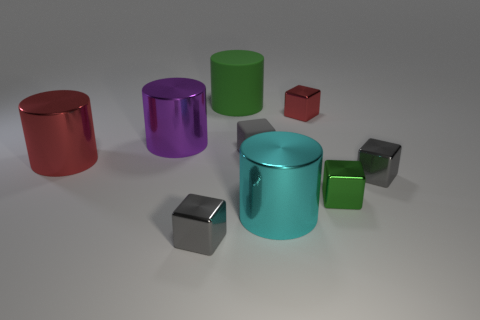Subtract all big metallic cylinders. How many cylinders are left? 1 Subtract all gray cylinders. How many gray cubes are left? 3 Subtract all red cylinders. How many cylinders are left? 3 Subtract 3 cylinders. How many cylinders are left? 1 Subtract 0 yellow cubes. How many objects are left? 9 Subtract all cubes. How many objects are left? 4 Subtract all purple cylinders. Subtract all yellow spheres. How many cylinders are left? 3 Subtract all big blue cylinders. Subtract all large red cylinders. How many objects are left? 8 Add 5 red metal cylinders. How many red metal cylinders are left? 6 Add 8 cyan metallic things. How many cyan metallic things exist? 9 